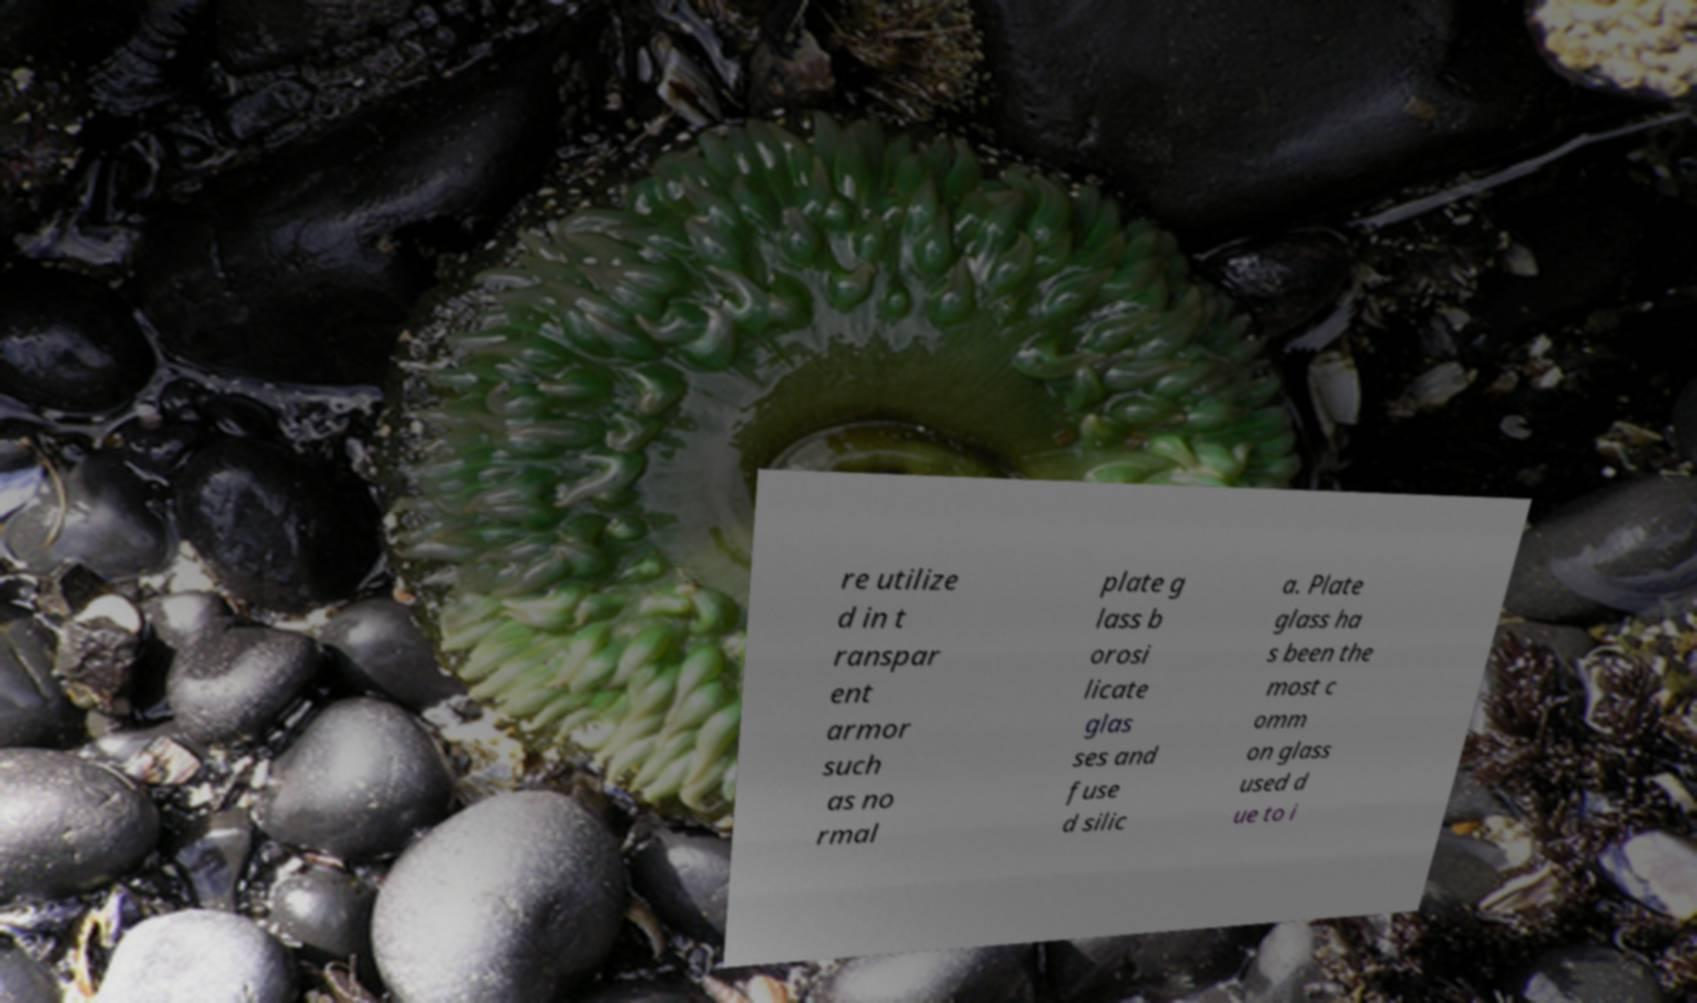Can you accurately transcribe the text from the provided image for me? re utilize d in t ranspar ent armor such as no rmal plate g lass b orosi licate glas ses and fuse d silic a. Plate glass ha s been the most c omm on glass used d ue to i 